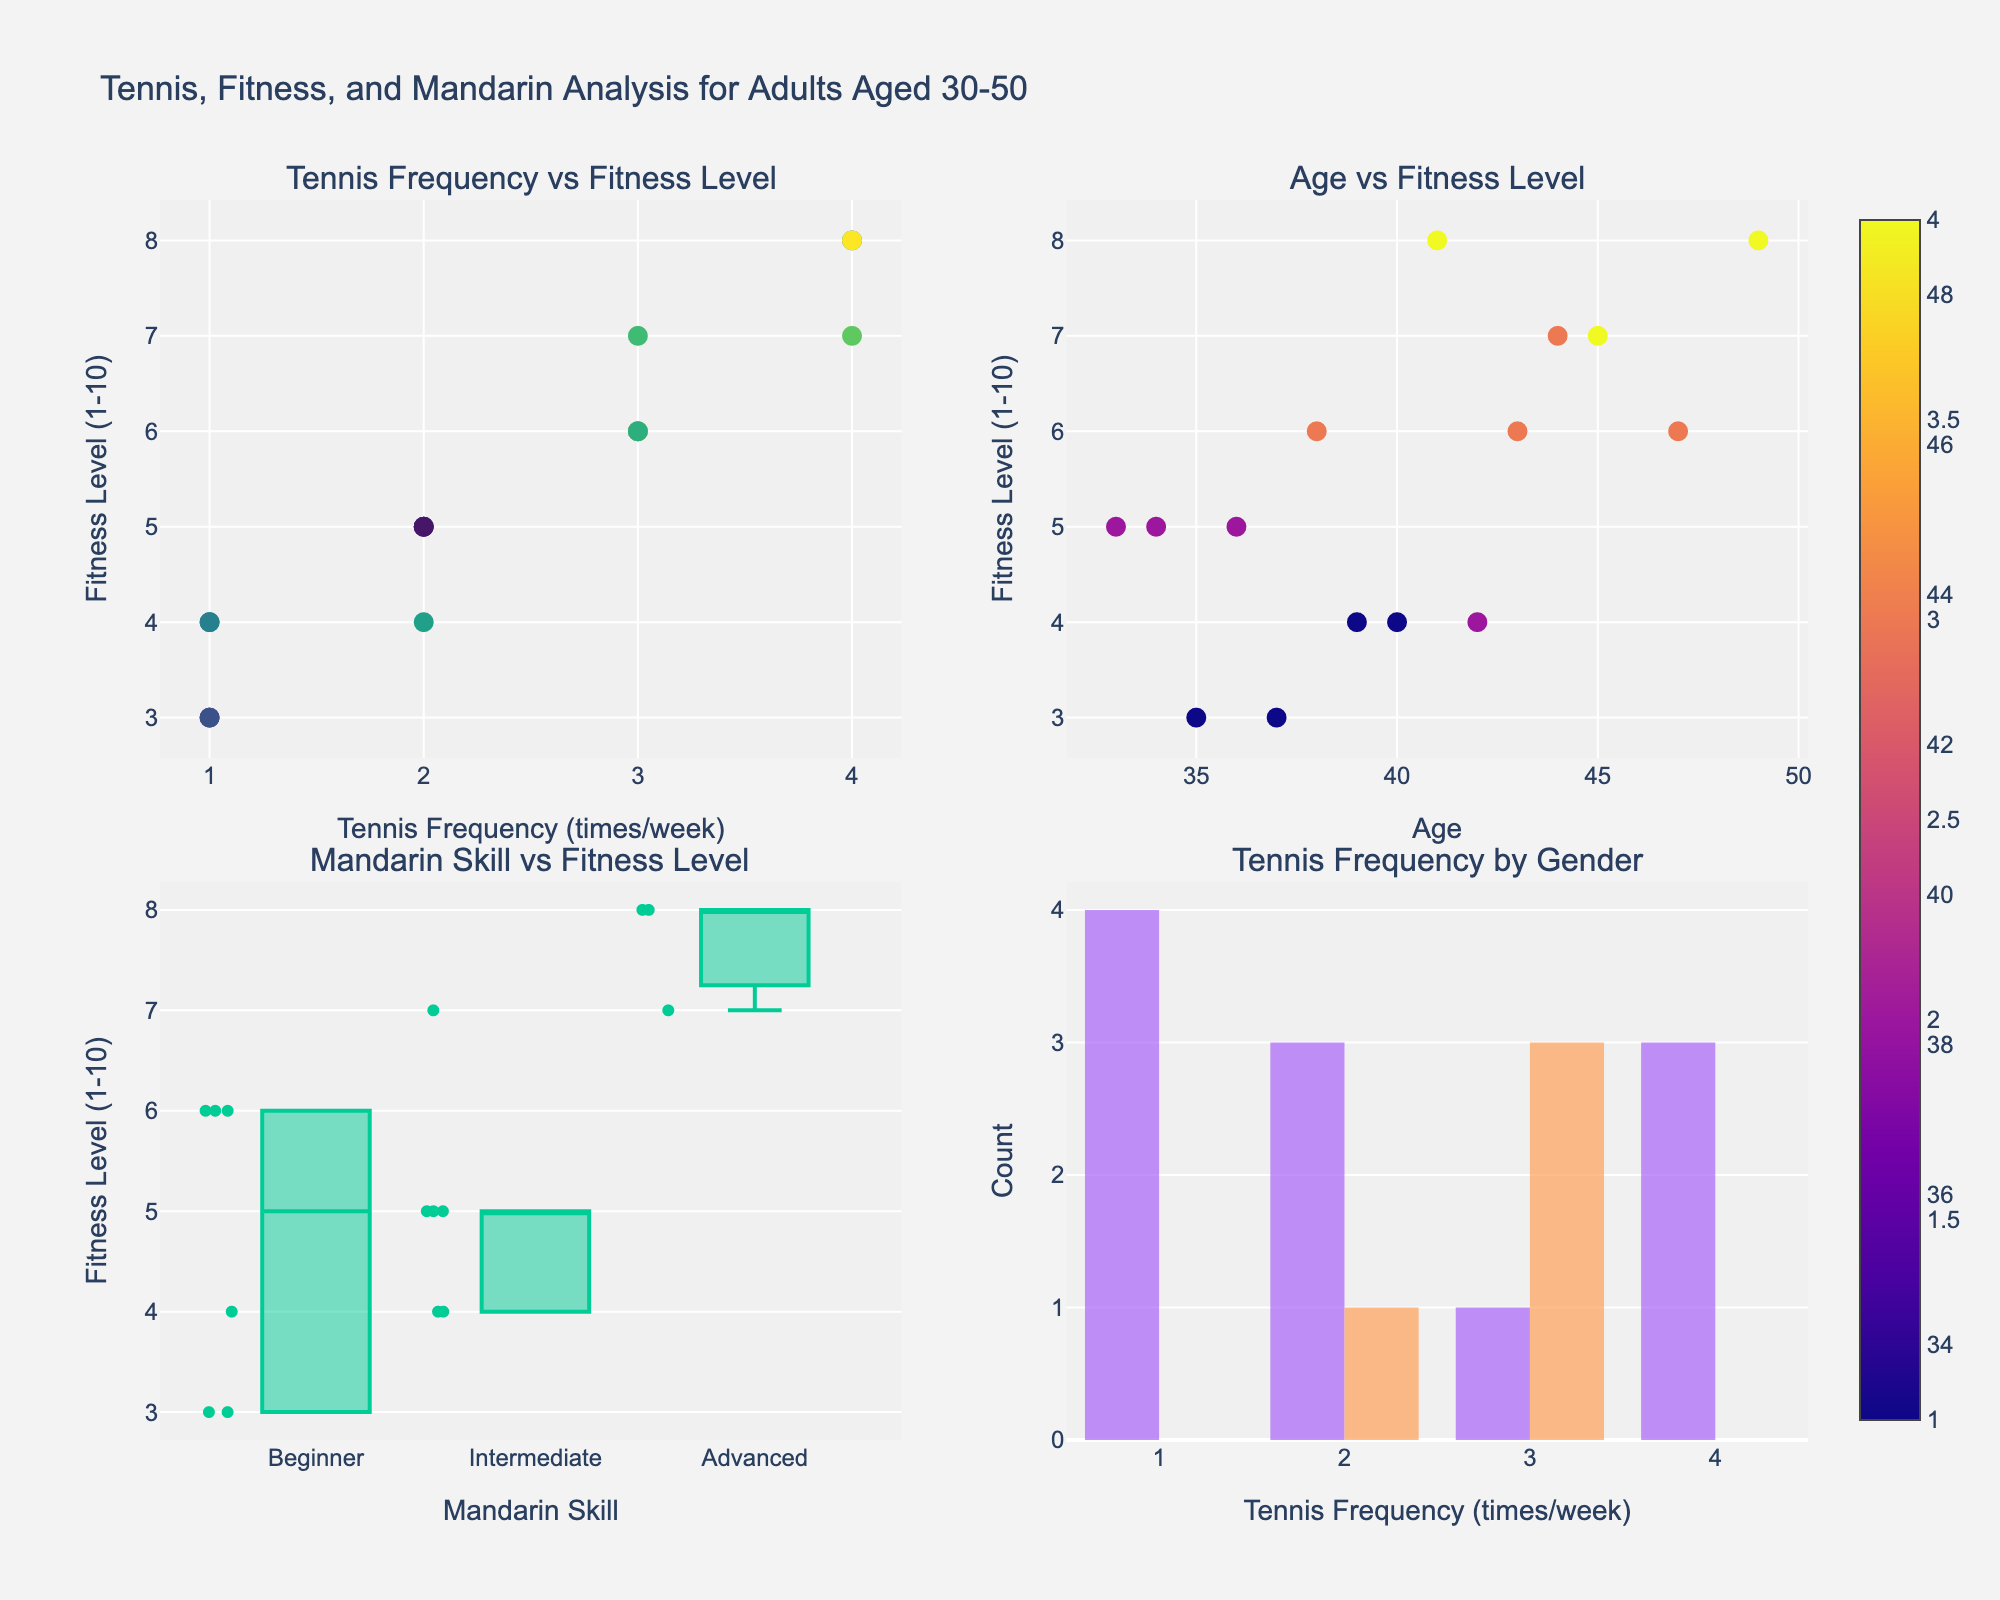What's the relationship between tennis frequency and fitness level? The scatter plot in the top-left corner shows that as tennis frequency (number of times playing per week) increases, fitness levels tend to increase as well. The trend generally shows an upward slope.
Answer: Positive correlation How does age relate to fitness level in this dataset? The scatter plot in the top-right corner indicates that fitness level varies with age, but there is no clear linear pattern. Fitness levels range widely across different ages from 30-50.
Answer: No clear pattern Which Mandarin skill level group has the highest fitness level? The box plot in the bottom-left corner shows that the 'Advanced' group generally has the highest fitness levels. The median value and upper whisker of the Advanced group are higher compared to the other skill levels.
Answer: Advanced How does tennis frequency distribution differ by gender? The histogram in the bottom-right corner shows that both genders have varied tennis frequencies, but females play more frequently overall compared to males.
Answer: Females play more frequently What is the fitness level for those aged 45 playing tennis 4 times a week? For those aged 45 playing tennis 4 times a week, we can observe from the scatter plots that they have a fitness level of 7.
Answer: 7 Are there more males or females in the dataset? Referencing the histogram in the bottom-right corner, more females appear in the histogram bars compared to males.
Answer: Females Which tennis frequency corresponds to the highest cluster of fitness levels? The scatter plot in the top-left corner indicates that the highest cluster of fitness levels is around a tennis frequency of 4 times per week.
Answer: 4 times/week What color indicates older ages in the scatter plots? The scatter plot in the top-left corner uses a color scale to indicate age, where darker shades represent older ages.
Answer: Darker shades What is the maximum fitness level observed, and in which sub-groups does it occur? The maximum fitness level observed is 8, occurring in the 'Tennis Frequency vs Fitness Level' plot for ages around 41 and 49, and for 'Advanced' Mandarin skill level users in the bottom-left box plot.
Answer: 8 How does fitness level vary with Mandarin skill levels? The box plot shows that 'Beginner' Mandarin speakers tend to have lower fitness levels, while 'Advanced' have higher fitness levels. 'Intermediate' speakers have fitness levels that are generally in between.
Answer: Lower for Beginner, Higher for Advanced Who has the highest age, and what is their tennis frequency and fitness level? The highest age is 49. From the scatter plots, this individual plays tennis 4 times per week and has a fitness level of 8.
Answer: 4 times/week and 8 